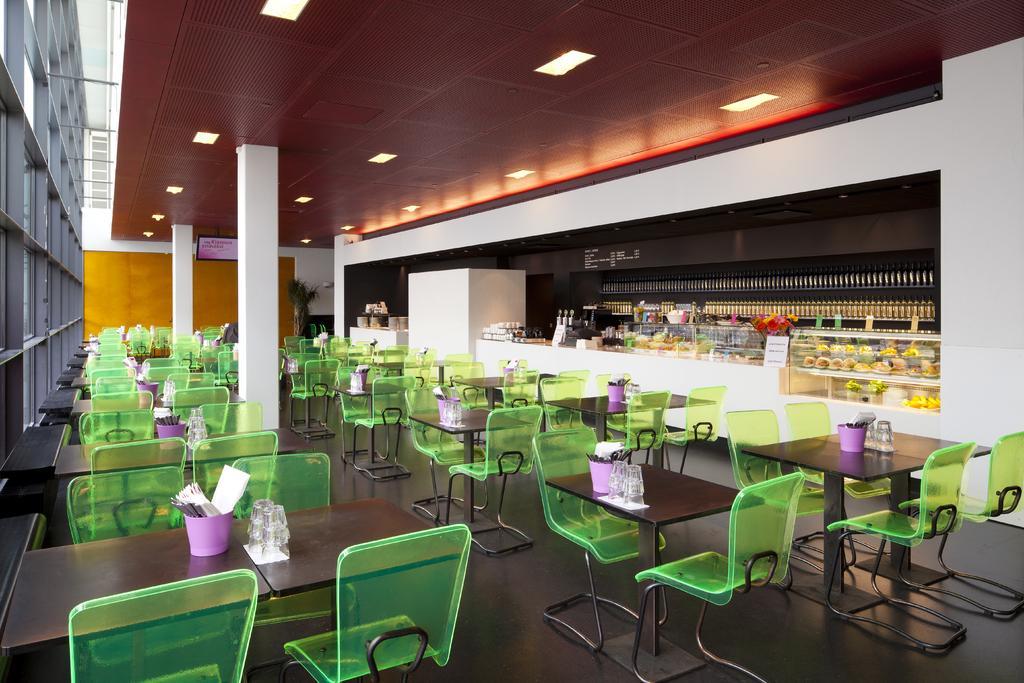How would you summarize this image in a sentence or two? In this picture I can see few chairs and tables and I can see napkins in the bowls and couple of glasses on all the tables and I can see lights on the ceiling and a plant and I can see few food items in the the glass boxes and looks like few bottles in the racks. 